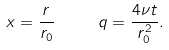<formula> <loc_0><loc_0><loc_500><loc_500>x = \frac { r } { r _ { 0 } } \quad & \ \ q = \frac { 4 \nu t } { r _ { 0 } ^ { 2 } } .</formula> 